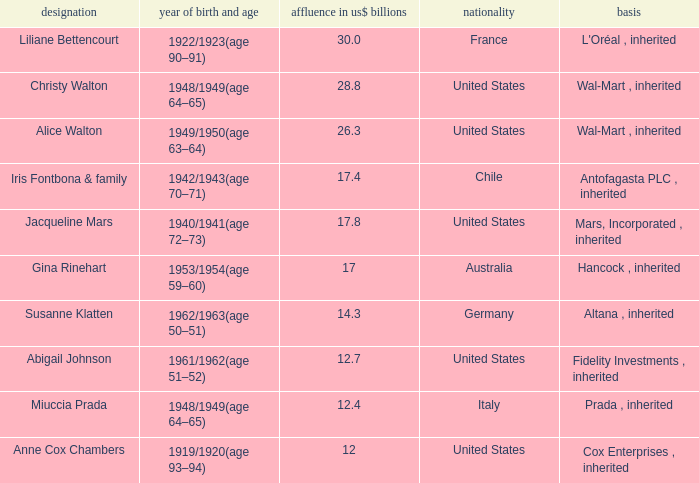What's the source of wealth of the person worth $17 billion? Hancock , inherited. 